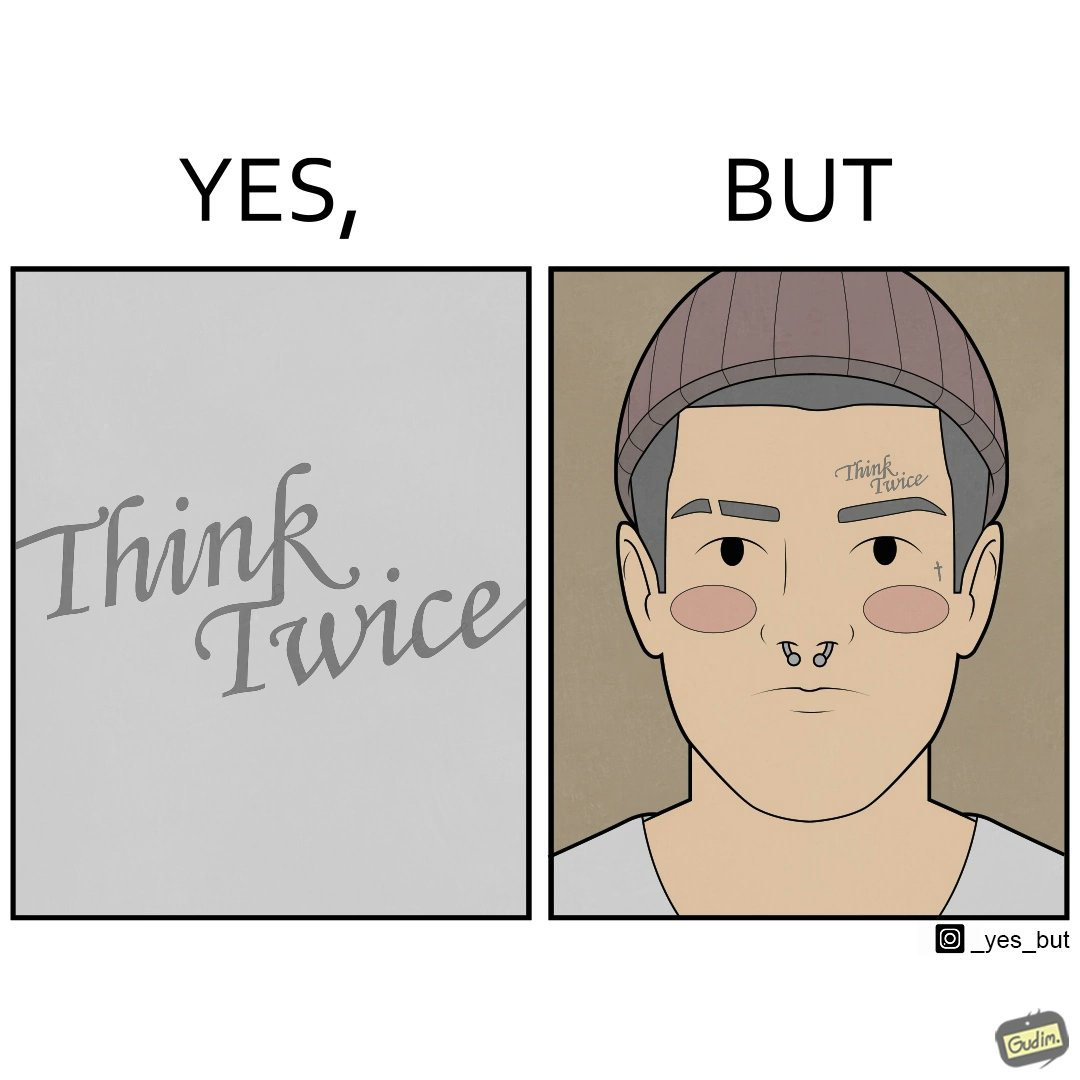Explain the humor or irony in this image. The image is funny because even thought the tattoo on the face of the man says "think twice", the man did not think twice before getting the tattoo on his forehead. 